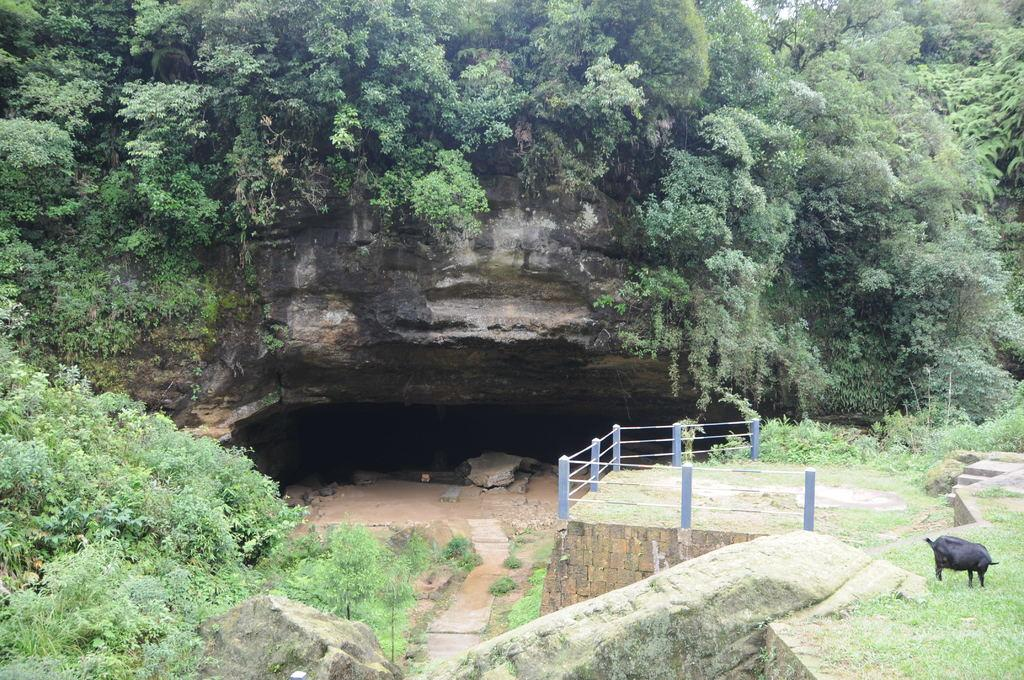What is the main subject in the foreground of the image? There is an animal in the foreground of the image. What is the animal standing on? The animal is on the grass. What architectural feature can be seen in the image? There is railing visible in the image. What type of natural environment is present in the image? There are trees in the image. What geological feature is present in the image? There is a rock in the image. What man-made structure is present in the image? There is a cave in the image. What type of dress is the animal wearing in the image? There is no dress present in the image, as animals do not wear clothing. 